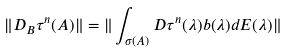Convert formula to latex. <formula><loc_0><loc_0><loc_500><loc_500>\| D _ { B } { \tau } ^ { n } ( A ) \| = \| \int _ { { \sigma } ( A ) } D { \tau } ^ { n } ( { \lambda } ) b ( { \lambda } ) d E ( { \lambda } ) \|</formula> 